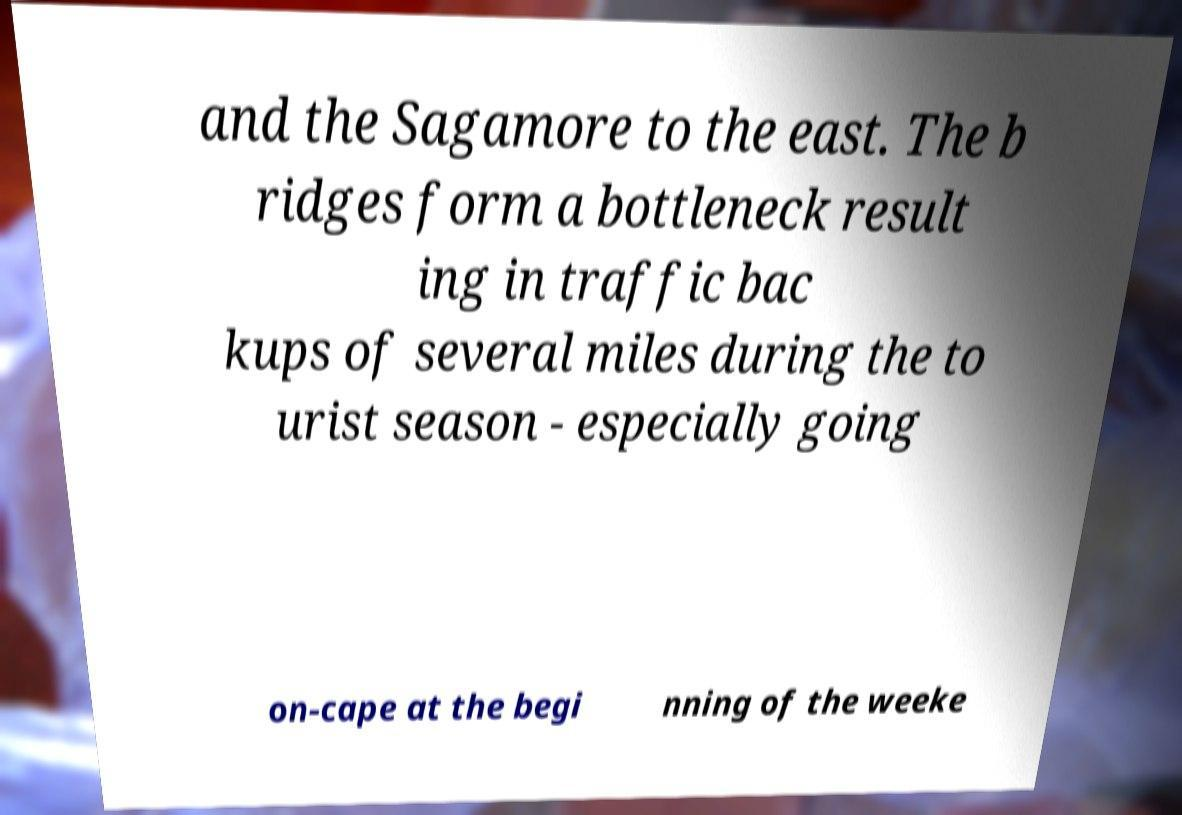Can you accurately transcribe the text from the provided image for me? and the Sagamore to the east. The b ridges form a bottleneck result ing in traffic bac kups of several miles during the to urist season - especially going on-cape at the begi nning of the weeke 